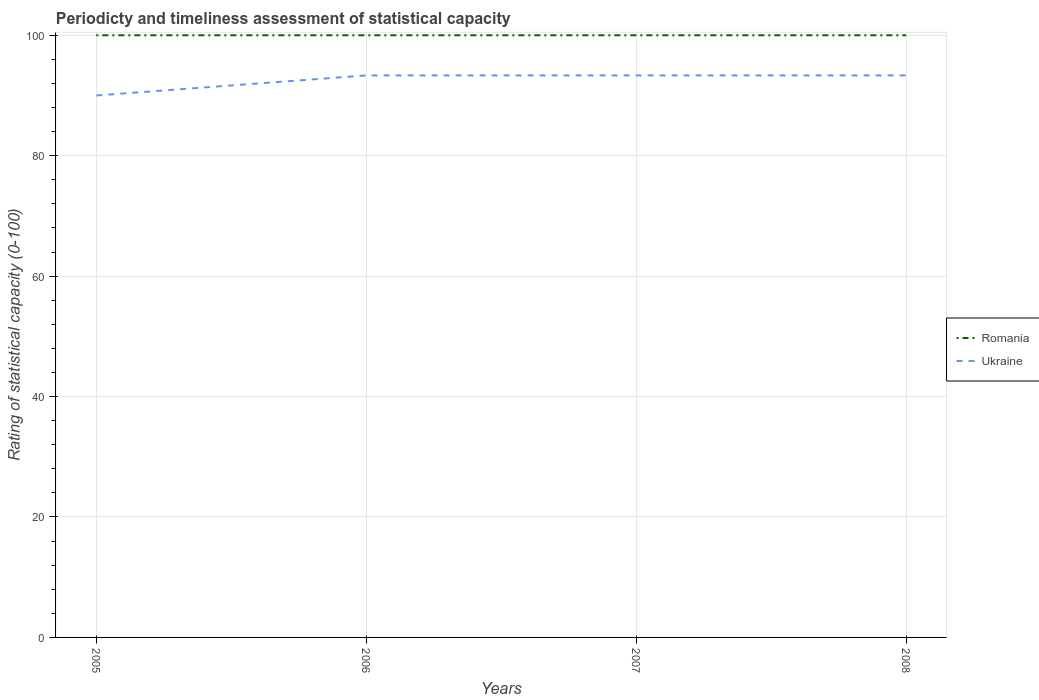How many different coloured lines are there?
Give a very brief answer. 2. Does the line corresponding to Romania intersect with the line corresponding to Ukraine?
Offer a terse response. No. Across all years, what is the maximum rating of statistical capacity in Ukraine?
Offer a very short reply. 90. In which year was the rating of statistical capacity in Ukraine maximum?
Ensure brevity in your answer.  2005. What is the difference between the highest and the second highest rating of statistical capacity in Ukraine?
Offer a very short reply. 3.33. What is the difference between the highest and the lowest rating of statistical capacity in Ukraine?
Ensure brevity in your answer.  3. Is the rating of statistical capacity in Romania strictly greater than the rating of statistical capacity in Ukraine over the years?
Your response must be concise. No. Does the graph contain any zero values?
Ensure brevity in your answer.  No. How many legend labels are there?
Provide a succinct answer. 2. How are the legend labels stacked?
Keep it short and to the point. Vertical. What is the title of the graph?
Offer a terse response. Periodicty and timeliness assessment of statistical capacity. Does "Belize" appear as one of the legend labels in the graph?
Offer a very short reply. No. What is the label or title of the X-axis?
Provide a short and direct response. Years. What is the label or title of the Y-axis?
Make the answer very short. Rating of statistical capacity (0-100). What is the Rating of statistical capacity (0-100) in Romania in 2005?
Your response must be concise. 100. What is the Rating of statistical capacity (0-100) of Romania in 2006?
Keep it short and to the point. 100. What is the Rating of statistical capacity (0-100) of Ukraine in 2006?
Ensure brevity in your answer.  93.33. What is the Rating of statistical capacity (0-100) of Ukraine in 2007?
Offer a terse response. 93.33. What is the Rating of statistical capacity (0-100) in Ukraine in 2008?
Offer a terse response. 93.33. Across all years, what is the maximum Rating of statistical capacity (0-100) in Ukraine?
Give a very brief answer. 93.33. Across all years, what is the minimum Rating of statistical capacity (0-100) in Ukraine?
Your answer should be very brief. 90. What is the total Rating of statistical capacity (0-100) in Romania in the graph?
Offer a terse response. 400. What is the total Rating of statistical capacity (0-100) in Ukraine in the graph?
Your answer should be very brief. 370. What is the difference between the Rating of statistical capacity (0-100) in Romania in 2005 and that in 2006?
Provide a succinct answer. 0. What is the difference between the Rating of statistical capacity (0-100) in Romania in 2005 and that in 2007?
Your response must be concise. 0. What is the difference between the Rating of statistical capacity (0-100) of Ukraine in 2005 and that in 2007?
Provide a short and direct response. -3.33. What is the difference between the Rating of statistical capacity (0-100) of Romania in 2005 and that in 2008?
Ensure brevity in your answer.  0. What is the difference between the Rating of statistical capacity (0-100) of Ukraine in 2005 and that in 2008?
Make the answer very short. -3.33. What is the difference between the Rating of statistical capacity (0-100) of Romania in 2006 and that in 2008?
Offer a terse response. 0. What is the difference between the Rating of statistical capacity (0-100) of Romania in 2007 and that in 2008?
Offer a terse response. 0. What is the difference between the Rating of statistical capacity (0-100) of Romania in 2005 and the Rating of statistical capacity (0-100) of Ukraine in 2007?
Your answer should be very brief. 6.67. What is the difference between the Rating of statistical capacity (0-100) of Romania in 2005 and the Rating of statistical capacity (0-100) of Ukraine in 2008?
Your answer should be compact. 6.67. What is the difference between the Rating of statistical capacity (0-100) of Romania in 2006 and the Rating of statistical capacity (0-100) of Ukraine in 2007?
Offer a terse response. 6.67. What is the difference between the Rating of statistical capacity (0-100) in Romania in 2006 and the Rating of statistical capacity (0-100) in Ukraine in 2008?
Make the answer very short. 6.67. What is the difference between the Rating of statistical capacity (0-100) of Romania in 2007 and the Rating of statistical capacity (0-100) of Ukraine in 2008?
Provide a succinct answer. 6.67. What is the average Rating of statistical capacity (0-100) of Romania per year?
Your response must be concise. 100. What is the average Rating of statistical capacity (0-100) in Ukraine per year?
Your answer should be very brief. 92.5. In the year 2006, what is the difference between the Rating of statistical capacity (0-100) in Romania and Rating of statistical capacity (0-100) in Ukraine?
Your response must be concise. 6.67. In the year 2007, what is the difference between the Rating of statistical capacity (0-100) in Romania and Rating of statistical capacity (0-100) in Ukraine?
Keep it short and to the point. 6.67. In the year 2008, what is the difference between the Rating of statistical capacity (0-100) in Romania and Rating of statistical capacity (0-100) in Ukraine?
Ensure brevity in your answer.  6.67. What is the ratio of the Rating of statistical capacity (0-100) of Romania in 2005 to that in 2006?
Your response must be concise. 1. What is the ratio of the Rating of statistical capacity (0-100) in Romania in 2005 to that in 2008?
Keep it short and to the point. 1. What is the ratio of the Rating of statistical capacity (0-100) in Romania in 2006 to that in 2008?
Your answer should be very brief. 1. What is the difference between the highest and the second highest Rating of statistical capacity (0-100) of Ukraine?
Keep it short and to the point. 0. What is the difference between the highest and the lowest Rating of statistical capacity (0-100) of Romania?
Your answer should be very brief. 0. 